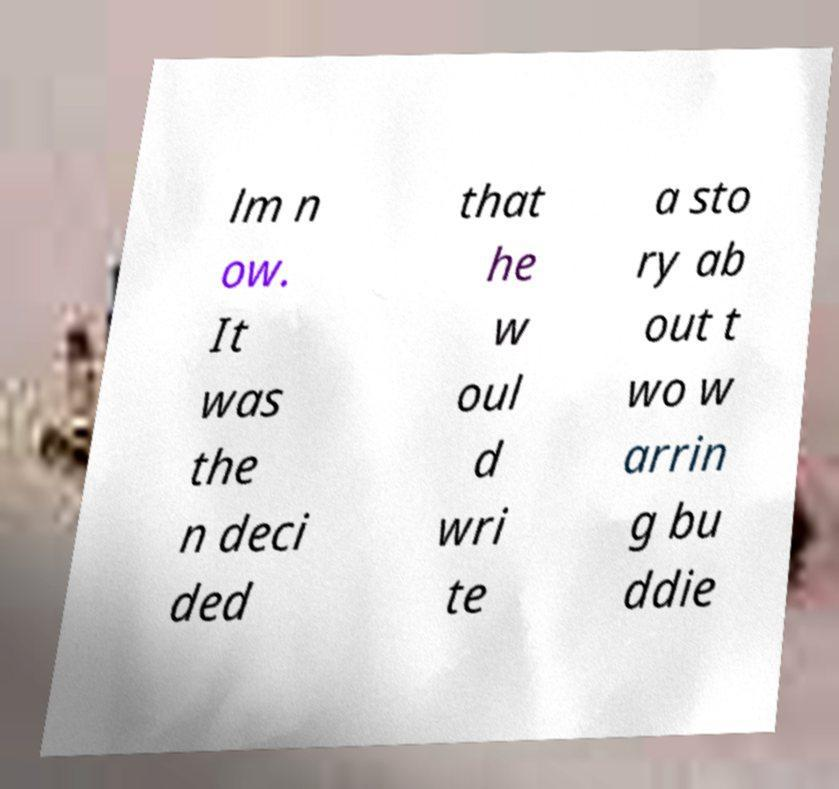Please identify and transcribe the text found in this image. lm n ow. It was the n deci ded that he w oul d wri te a sto ry ab out t wo w arrin g bu ddie 